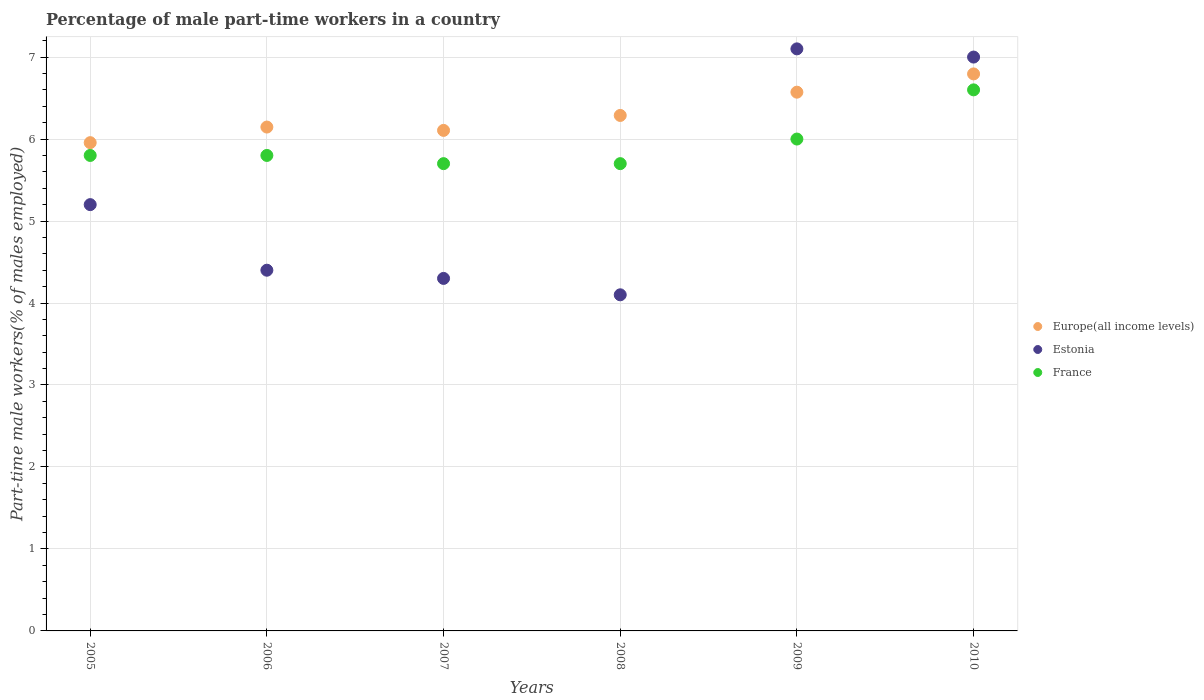How many different coloured dotlines are there?
Ensure brevity in your answer.  3. Is the number of dotlines equal to the number of legend labels?
Your response must be concise. Yes. What is the percentage of male part-time workers in France in 2005?
Offer a very short reply. 5.8. Across all years, what is the maximum percentage of male part-time workers in Estonia?
Make the answer very short. 7.1. Across all years, what is the minimum percentage of male part-time workers in Estonia?
Make the answer very short. 4.1. In which year was the percentage of male part-time workers in Europe(all income levels) maximum?
Offer a terse response. 2010. In which year was the percentage of male part-time workers in Estonia minimum?
Provide a short and direct response. 2008. What is the total percentage of male part-time workers in Europe(all income levels) in the graph?
Your response must be concise. 37.86. What is the difference between the percentage of male part-time workers in Estonia in 2006 and that in 2007?
Ensure brevity in your answer.  0.1. What is the difference between the percentage of male part-time workers in Europe(all income levels) in 2006 and the percentage of male part-time workers in France in 2005?
Ensure brevity in your answer.  0.35. What is the average percentage of male part-time workers in Estonia per year?
Your answer should be very brief. 5.35. In the year 2006, what is the difference between the percentage of male part-time workers in Estonia and percentage of male part-time workers in Europe(all income levels)?
Your response must be concise. -1.75. What is the ratio of the percentage of male part-time workers in Estonia in 2009 to that in 2010?
Your response must be concise. 1.01. Is the percentage of male part-time workers in France in 2007 less than that in 2008?
Ensure brevity in your answer.  No. What is the difference between the highest and the second highest percentage of male part-time workers in Estonia?
Ensure brevity in your answer.  0.1. What is the difference between the highest and the lowest percentage of male part-time workers in Estonia?
Your answer should be compact. 3. Is the sum of the percentage of male part-time workers in Estonia in 2006 and 2010 greater than the maximum percentage of male part-time workers in Europe(all income levels) across all years?
Your response must be concise. Yes. Is it the case that in every year, the sum of the percentage of male part-time workers in Estonia and percentage of male part-time workers in Europe(all income levels)  is greater than the percentage of male part-time workers in France?
Your answer should be compact. Yes. Is the percentage of male part-time workers in France strictly greater than the percentage of male part-time workers in Europe(all income levels) over the years?
Make the answer very short. No. Is the percentage of male part-time workers in Europe(all income levels) strictly less than the percentage of male part-time workers in France over the years?
Your answer should be very brief. No. How many years are there in the graph?
Your response must be concise. 6. What is the difference between two consecutive major ticks on the Y-axis?
Ensure brevity in your answer.  1. Where does the legend appear in the graph?
Give a very brief answer. Center right. What is the title of the graph?
Offer a terse response. Percentage of male part-time workers in a country. What is the label or title of the X-axis?
Give a very brief answer. Years. What is the label or title of the Y-axis?
Ensure brevity in your answer.  Part-time male workers(% of males employed). What is the Part-time male workers(% of males employed) in Europe(all income levels) in 2005?
Keep it short and to the point. 5.96. What is the Part-time male workers(% of males employed) in Estonia in 2005?
Your answer should be compact. 5.2. What is the Part-time male workers(% of males employed) in France in 2005?
Offer a terse response. 5.8. What is the Part-time male workers(% of males employed) in Europe(all income levels) in 2006?
Keep it short and to the point. 6.15. What is the Part-time male workers(% of males employed) in Estonia in 2006?
Keep it short and to the point. 4.4. What is the Part-time male workers(% of males employed) of France in 2006?
Offer a terse response. 5.8. What is the Part-time male workers(% of males employed) of Europe(all income levels) in 2007?
Give a very brief answer. 6.11. What is the Part-time male workers(% of males employed) in Estonia in 2007?
Offer a terse response. 4.3. What is the Part-time male workers(% of males employed) of France in 2007?
Offer a terse response. 5.7. What is the Part-time male workers(% of males employed) in Europe(all income levels) in 2008?
Keep it short and to the point. 6.29. What is the Part-time male workers(% of males employed) of Estonia in 2008?
Give a very brief answer. 4.1. What is the Part-time male workers(% of males employed) in France in 2008?
Your answer should be very brief. 5.7. What is the Part-time male workers(% of males employed) of Europe(all income levels) in 2009?
Your answer should be compact. 6.57. What is the Part-time male workers(% of males employed) of Estonia in 2009?
Keep it short and to the point. 7.1. What is the Part-time male workers(% of males employed) in Europe(all income levels) in 2010?
Make the answer very short. 6.79. What is the Part-time male workers(% of males employed) of Estonia in 2010?
Give a very brief answer. 7. What is the Part-time male workers(% of males employed) in France in 2010?
Your answer should be compact. 6.6. Across all years, what is the maximum Part-time male workers(% of males employed) of Europe(all income levels)?
Provide a short and direct response. 6.79. Across all years, what is the maximum Part-time male workers(% of males employed) in Estonia?
Your response must be concise. 7.1. Across all years, what is the maximum Part-time male workers(% of males employed) of France?
Offer a very short reply. 6.6. Across all years, what is the minimum Part-time male workers(% of males employed) of Europe(all income levels)?
Ensure brevity in your answer.  5.96. Across all years, what is the minimum Part-time male workers(% of males employed) of Estonia?
Your answer should be compact. 4.1. Across all years, what is the minimum Part-time male workers(% of males employed) of France?
Offer a very short reply. 5.7. What is the total Part-time male workers(% of males employed) of Europe(all income levels) in the graph?
Provide a succinct answer. 37.86. What is the total Part-time male workers(% of males employed) of Estonia in the graph?
Your answer should be compact. 32.1. What is the total Part-time male workers(% of males employed) in France in the graph?
Keep it short and to the point. 35.6. What is the difference between the Part-time male workers(% of males employed) in Europe(all income levels) in 2005 and that in 2006?
Provide a succinct answer. -0.19. What is the difference between the Part-time male workers(% of males employed) of Estonia in 2005 and that in 2006?
Your answer should be compact. 0.8. What is the difference between the Part-time male workers(% of males employed) in Europe(all income levels) in 2005 and that in 2007?
Provide a succinct answer. -0.15. What is the difference between the Part-time male workers(% of males employed) of France in 2005 and that in 2007?
Keep it short and to the point. 0.1. What is the difference between the Part-time male workers(% of males employed) of Europe(all income levels) in 2005 and that in 2008?
Your answer should be compact. -0.33. What is the difference between the Part-time male workers(% of males employed) of France in 2005 and that in 2008?
Your response must be concise. 0.1. What is the difference between the Part-time male workers(% of males employed) of Europe(all income levels) in 2005 and that in 2009?
Offer a very short reply. -0.62. What is the difference between the Part-time male workers(% of males employed) in Estonia in 2005 and that in 2009?
Offer a terse response. -1.9. What is the difference between the Part-time male workers(% of males employed) in Europe(all income levels) in 2005 and that in 2010?
Offer a terse response. -0.84. What is the difference between the Part-time male workers(% of males employed) of Europe(all income levels) in 2006 and that in 2007?
Ensure brevity in your answer.  0.04. What is the difference between the Part-time male workers(% of males employed) of France in 2006 and that in 2007?
Provide a succinct answer. 0.1. What is the difference between the Part-time male workers(% of males employed) in Europe(all income levels) in 2006 and that in 2008?
Offer a very short reply. -0.14. What is the difference between the Part-time male workers(% of males employed) in France in 2006 and that in 2008?
Your answer should be compact. 0.1. What is the difference between the Part-time male workers(% of males employed) of Europe(all income levels) in 2006 and that in 2009?
Keep it short and to the point. -0.43. What is the difference between the Part-time male workers(% of males employed) in Europe(all income levels) in 2006 and that in 2010?
Keep it short and to the point. -0.65. What is the difference between the Part-time male workers(% of males employed) in Estonia in 2006 and that in 2010?
Your answer should be very brief. -2.6. What is the difference between the Part-time male workers(% of males employed) in Europe(all income levels) in 2007 and that in 2008?
Offer a very short reply. -0.18. What is the difference between the Part-time male workers(% of males employed) in France in 2007 and that in 2008?
Offer a terse response. 0. What is the difference between the Part-time male workers(% of males employed) in Europe(all income levels) in 2007 and that in 2009?
Keep it short and to the point. -0.47. What is the difference between the Part-time male workers(% of males employed) in France in 2007 and that in 2009?
Make the answer very short. -0.3. What is the difference between the Part-time male workers(% of males employed) in Europe(all income levels) in 2007 and that in 2010?
Offer a very short reply. -0.69. What is the difference between the Part-time male workers(% of males employed) of France in 2007 and that in 2010?
Your answer should be very brief. -0.9. What is the difference between the Part-time male workers(% of males employed) of Europe(all income levels) in 2008 and that in 2009?
Make the answer very short. -0.28. What is the difference between the Part-time male workers(% of males employed) of Europe(all income levels) in 2008 and that in 2010?
Keep it short and to the point. -0.51. What is the difference between the Part-time male workers(% of males employed) of Estonia in 2008 and that in 2010?
Keep it short and to the point. -2.9. What is the difference between the Part-time male workers(% of males employed) in France in 2008 and that in 2010?
Offer a terse response. -0.9. What is the difference between the Part-time male workers(% of males employed) in Europe(all income levels) in 2009 and that in 2010?
Your answer should be very brief. -0.22. What is the difference between the Part-time male workers(% of males employed) of France in 2009 and that in 2010?
Offer a very short reply. -0.6. What is the difference between the Part-time male workers(% of males employed) of Europe(all income levels) in 2005 and the Part-time male workers(% of males employed) of Estonia in 2006?
Your answer should be compact. 1.56. What is the difference between the Part-time male workers(% of males employed) of Europe(all income levels) in 2005 and the Part-time male workers(% of males employed) of France in 2006?
Offer a very short reply. 0.16. What is the difference between the Part-time male workers(% of males employed) in Estonia in 2005 and the Part-time male workers(% of males employed) in France in 2006?
Your answer should be compact. -0.6. What is the difference between the Part-time male workers(% of males employed) of Europe(all income levels) in 2005 and the Part-time male workers(% of males employed) of Estonia in 2007?
Provide a succinct answer. 1.66. What is the difference between the Part-time male workers(% of males employed) in Europe(all income levels) in 2005 and the Part-time male workers(% of males employed) in France in 2007?
Provide a succinct answer. 0.26. What is the difference between the Part-time male workers(% of males employed) of Estonia in 2005 and the Part-time male workers(% of males employed) of France in 2007?
Keep it short and to the point. -0.5. What is the difference between the Part-time male workers(% of males employed) in Europe(all income levels) in 2005 and the Part-time male workers(% of males employed) in Estonia in 2008?
Keep it short and to the point. 1.86. What is the difference between the Part-time male workers(% of males employed) in Europe(all income levels) in 2005 and the Part-time male workers(% of males employed) in France in 2008?
Provide a succinct answer. 0.26. What is the difference between the Part-time male workers(% of males employed) of Europe(all income levels) in 2005 and the Part-time male workers(% of males employed) of Estonia in 2009?
Offer a terse response. -1.14. What is the difference between the Part-time male workers(% of males employed) of Europe(all income levels) in 2005 and the Part-time male workers(% of males employed) of France in 2009?
Your response must be concise. -0.04. What is the difference between the Part-time male workers(% of males employed) of Europe(all income levels) in 2005 and the Part-time male workers(% of males employed) of Estonia in 2010?
Offer a very short reply. -1.04. What is the difference between the Part-time male workers(% of males employed) of Europe(all income levels) in 2005 and the Part-time male workers(% of males employed) of France in 2010?
Make the answer very short. -0.64. What is the difference between the Part-time male workers(% of males employed) in Estonia in 2005 and the Part-time male workers(% of males employed) in France in 2010?
Give a very brief answer. -1.4. What is the difference between the Part-time male workers(% of males employed) of Europe(all income levels) in 2006 and the Part-time male workers(% of males employed) of Estonia in 2007?
Keep it short and to the point. 1.85. What is the difference between the Part-time male workers(% of males employed) of Europe(all income levels) in 2006 and the Part-time male workers(% of males employed) of France in 2007?
Your response must be concise. 0.45. What is the difference between the Part-time male workers(% of males employed) in Europe(all income levels) in 2006 and the Part-time male workers(% of males employed) in Estonia in 2008?
Provide a short and direct response. 2.05. What is the difference between the Part-time male workers(% of males employed) in Europe(all income levels) in 2006 and the Part-time male workers(% of males employed) in France in 2008?
Your answer should be compact. 0.45. What is the difference between the Part-time male workers(% of males employed) in Europe(all income levels) in 2006 and the Part-time male workers(% of males employed) in Estonia in 2009?
Give a very brief answer. -0.95. What is the difference between the Part-time male workers(% of males employed) of Europe(all income levels) in 2006 and the Part-time male workers(% of males employed) of France in 2009?
Provide a succinct answer. 0.15. What is the difference between the Part-time male workers(% of males employed) of Estonia in 2006 and the Part-time male workers(% of males employed) of France in 2009?
Your answer should be very brief. -1.6. What is the difference between the Part-time male workers(% of males employed) of Europe(all income levels) in 2006 and the Part-time male workers(% of males employed) of Estonia in 2010?
Give a very brief answer. -0.85. What is the difference between the Part-time male workers(% of males employed) of Europe(all income levels) in 2006 and the Part-time male workers(% of males employed) of France in 2010?
Make the answer very short. -0.45. What is the difference between the Part-time male workers(% of males employed) of Europe(all income levels) in 2007 and the Part-time male workers(% of males employed) of Estonia in 2008?
Make the answer very short. 2.01. What is the difference between the Part-time male workers(% of males employed) in Europe(all income levels) in 2007 and the Part-time male workers(% of males employed) in France in 2008?
Make the answer very short. 0.41. What is the difference between the Part-time male workers(% of males employed) in Estonia in 2007 and the Part-time male workers(% of males employed) in France in 2008?
Make the answer very short. -1.4. What is the difference between the Part-time male workers(% of males employed) in Europe(all income levels) in 2007 and the Part-time male workers(% of males employed) in Estonia in 2009?
Keep it short and to the point. -0.99. What is the difference between the Part-time male workers(% of males employed) of Europe(all income levels) in 2007 and the Part-time male workers(% of males employed) of France in 2009?
Provide a short and direct response. 0.11. What is the difference between the Part-time male workers(% of males employed) of Estonia in 2007 and the Part-time male workers(% of males employed) of France in 2009?
Your response must be concise. -1.7. What is the difference between the Part-time male workers(% of males employed) of Europe(all income levels) in 2007 and the Part-time male workers(% of males employed) of Estonia in 2010?
Make the answer very short. -0.89. What is the difference between the Part-time male workers(% of males employed) of Europe(all income levels) in 2007 and the Part-time male workers(% of males employed) of France in 2010?
Your response must be concise. -0.49. What is the difference between the Part-time male workers(% of males employed) in Europe(all income levels) in 2008 and the Part-time male workers(% of males employed) in Estonia in 2009?
Offer a very short reply. -0.81. What is the difference between the Part-time male workers(% of males employed) of Europe(all income levels) in 2008 and the Part-time male workers(% of males employed) of France in 2009?
Keep it short and to the point. 0.29. What is the difference between the Part-time male workers(% of males employed) of Estonia in 2008 and the Part-time male workers(% of males employed) of France in 2009?
Your answer should be very brief. -1.9. What is the difference between the Part-time male workers(% of males employed) of Europe(all income levels) in 2008 and the Part-time male workers(% of males employed) of Estonia in 2010?
Provide a succinct answer. -0.71. What is the difference between the Part-time male workers(% of males employed) of Europe(all income levels) in 2008 and the Part-time male workers(% of males employed) of France in 2010?
Keep it short and to the point. -0.31. What is the difference between the Part-time male workers(% of males employed) in Europe(all income levels) in 2009 and the Part-time male workers(% of males employed) in Estonia in 2010?
Your answer should be compact. -0.43. What is the difference between the Part-time male workers(% of males employed) in Europe(all income levels) in 2009 and the Part-time male workers(% of males employed) in France in 2010?
Keep it short and to the point. -0.03. What is the difference between the Part-time male workers(% of males employed) of Estonia in 2009 and the Part-time male workers(% of males employed) of France in 2010?
Provide a succinct answer. 0.5. What is the average Part-time male workers(% of males employed) of Europe(all income levels) per year?
Offer a terse response. 6.31. What is the average Part-time male workers(% of males employed) of Estonia per year?
Offer a very short reply. 5.35. What is the average Part-time male workers(% of males employed) of France per year?
Offer a very short reply. 5.93. In the year 2005, what is the difference between the Part-time male workers(% of males employed) in Europe(all income levels) and Part-time male workers(% of males employed) in Estonia?
Offer a very short reply. 0.76. In the year 2005, what is the difference between the Part-time male workers(% of males employed) of Europe(all income levels) and Part-time male workers(% of males employed) of France?
Provide a short and direct response. 0.16. In the year 2005, what is the difference between the Part-time male workers(% of males employed) in Estonia and Part-time male workers(% of males employed) in France?
Your response must be concise. -0.6. In the year 2006, what is the difference between the Part-time male workers(% of males employed) in Europe(all income levels) and Part-time male workers(% of males employed) in Estonia?
Provide a short and direct response. 1.75. In the year 2006, what is the difference between the Part-time male workers(% of males employed) of Europe(all income levels) and Part-time male workers(% of males employed) of France?
Your answer should be very brief. 0.35. In the year 2007, what is the difference between the Part-time male workers(% of males employed) of Europe(all income levels) and Part-time male workers(% of males employed) of Estonia?
Give a very brief answer. 1.81. In the year 2007, what is the difference between the Part-time male workers(% of males employed) of Europe(all income levels) and Part-time male workers(% of males employed) of France?
Offer a very short reply. 0.41. In the year 2008, what is the difference between the Part-time male workers(% of males employed) of Europe(all income levels) and Part-time male workers(% of males employed) of Estonia?
Offer a terse response. 2.19. In the year 2008, what is the difference between the Part-time male workers(% of males employed) in Europe(all income levels) and Part-time male workers(% of males employed) in France?
Offer a terse response. 0.59. In the year 2008, what is the difference between the Part-time male workers(% of males employed) in Estonia and Part-time male workers(% of males employed) in France?
Your answer should be compact. -1.6. In the year 2009, what is the difference between the Part-time male workers(% of males employed) of Europe(all income levels) and Part-time male workers(% of males employed) of Estonia?
Offer a very short reply. -0.53. In the year 2009, what is the difference between the Part-time male workers(% of males employed) of Europe(all income levels) and Part-time male workers(% of males employed) of France?
Make the answer very short. 0.57. In the year 2010, what is the difference between the Part-time male workers(% of males employed) of Europe(all income levels) and Part-time male workers(% of males employed) of Estonia?
Your response must be concise. -0.21. In the year 2010, what is the difference between the Part-time male workers(% of males employed) in Europe(all income levels) and Part-time male workers(% of males employed) in France?
Offer a terse response. 0.19. In the year 2010, what is the difference between the Part-time male workers(% of males employed) of Estonia and Part-time male workers(% of males employed) of France?
Ensure brevity in your answer.  0.4. What is the ratio of the Part-time male workers(% of males employed) of Estonia in 2005 to that in 2006?
Keep it short and to the point. 1.18. What is the ratio of the Part-time male workers(% of males employed) of France in 2005 to that in 2006?
Provide a short and direct response. 1. What is the ratio of the Part-time male workers(% of males employed) in Europe(all income levels) in 2005 to that in 2007?
Your answer should be compact. 0.98. What is the ratio of the Part-time male workers(% of males employed) in Estonia in 2005 to that in 2007?
Your answer should be compact. 1.21. What is the ratio of the Part-time male workers(% of males employed) of France in 2005 to that in 2007?
Provide a succinct answer. 1.02. What is the ratio of the Part-time male workers(% of males employed) of Europe(all income levels) in 2005 to that in 2008?
Provide a succinct answer. 0.95. What is the ratio of the Part-time male workers(% of males employed) in Estonia in 2005 to that in 2008?
Keep it short and to the point. 1.27. What is the ratio of the Part-time male workers(% of males employed) of France in 2005 to that in 2008?
Your response must be concise. 1.02. What is the ratio of the Part-time male workers(% of males employed) in Europe(all income levels) in 2005 to that in 2009?
Your response must be concise. 0.91. What is the ratio of the Part-time male workers(% of males employed) in Estonia in 2005 to that in 2009?
Your answer should be compact. 0.73. What is the ratio of the Part-time male workers(% of males employed) in France in 2005 to that in 2009?
Provide a short and direct response. 0.97. What is the ratio of the Part-time male workers(% of males employed) in Europe(all income levels) in 2005 to that in 2010?
Offer a very short reply. 0.88. What is the ratio of the Part-time male workers(% of males employed) of Estonia in 2005 to that in 2010?
Ensure brevity in your answer.  0.74. What is the ratio of the Part-time male workers(% of males employed) in France in 2005 to that in 2010?
Make the answer very short. 0.88. What is the ratio of the Part-time male workers(% of males employed) in Estonia in 2006 to that in 2007?
Provide a short and direct response. 1.02. What is the ratio of the Part-time male workers(% of males employed) of France in 2006 to that in 2007?
Ensure brevity in your answer.  1.02. What is the ratio of the Part-time male workers(% of males employed) in Europe(all income levels) in 2006 to that in 2008?
Provide a succinct answer. 0.98. What is the ratio of the Part-time male workers(% of males employed) of Estonia in 2006 to that in 2008?
Keep it short and to the point. 1.07. What is the ratio of the Part-time male workers(% of males employed) of France in 2006 to that in 2008?
Ensure brevity in your answer.  1.02. What is the ratio of the Part-time male workers(% of males employed) of Europe(all income levels) in 2006 to that in 2009?
Offer a very short reply. 0.94. What is the ratio of the Part-time male workers(% of males employed) in Estonia in 2006 to that in 2009?
Offer a terse response. 0.62. What is the ratio of the Part-time male workers(% of males employed) of France in 2006 to that in 2009?
Provide a short and direct response. 0.97. What is the ratio of the Part-time male workers(% of males employed) of Europe(all income levels) in 2006 to that in 2010?
Provide a short and direct response. 0.9. What is the ratio of the Part-time male workers(% of males employed) of Estonia in 2006 to that in 2010?
Provide a succinct answer. 0.63. What is the ratio of the Part-time male workers(% of males employed) of France in 2006 to that in 2010?
Keep it short and to the point. 0.88. What is the ratio of the Part-time male workers(% of males employed) of Estonia in 2007 to that in 2008?
Provide a short and direct response. 1.05. What is the ratio of the Part-time male workers(% of males employed) of Europe(all income levels) in 2007 to that in 2009?
Offer a very short reply. 0.93. What is the ratio of the Part-time male workers(% of males employed) in Estonia in 2007 to that in 2009?
Make the answer very short. 0.61. What is the ratio of the Part-time male workers(% of males employed) of Europe(all income levels) in 2007 to that in 2010?
Ensure brevity in your answer.  0.9. What is the ratio of the Part-time male workers(% of males employed) in Estonia in 2007 to that in 2010?
Keep it short and to the point. 0.61. What is the ratio of the Part-time male workers(% of males employed) in France in 2007 to that in 2010?
Your answer should be compact. 0.86. What is the ratio of the Part-time male workers(% of males employed) of Europe(all income levels) in 2008 to that in 2009?
Provide a succinct answer. 0.96. What is the ratio of the Part-time male workers(% of males employed) in Estonia in 2008 to that in 2009?
Ensure brevity in your answer.  0.58. What is the ratio of the Part-time male workers(% of males employed) of Europe(all income levels) in 2008 to that in 2010?
Offer a terse response. 0.93. What is the ratio of the Part-time male workers(% of males employed) of Estonia in 2008 to that in 2010?
Offer a terse response. 0.59. What is the ratio of the Part-time male workers(% of males employed) of France in 2008 to that in 2010?
Ensure brevity in your answer.  0.86. What is the ratio of the Part-time male workers(% of males employed) in Europe(all income levels) in 2009 to that in 2010?
Provide a succinct answer. 0.97. What is the ratio of the Part-time male workers(% of males employed) of Estonia in 2009 to that in 2010?
Offer a very short reply. 1.01. What is the ratio of the Part-time male workers(% of males employed) in France in 2009 to that in 2010?
Offer a terse response. 0.91. What is the difference between the highest and the second highest Part-time male workers(% of males employed) in Europe(all income levels)?
Ensure brevity in your answer.  0.22. What is the difference between the highest and the lowest Part-time male workers(% of males employed) in Europe(all income levels)?
Provide a succinct answer. 0.84. What is the difference between the highest and the lowest Part-time male workers(% of males employed) of Estonia?
Offer a terse response. 3. 